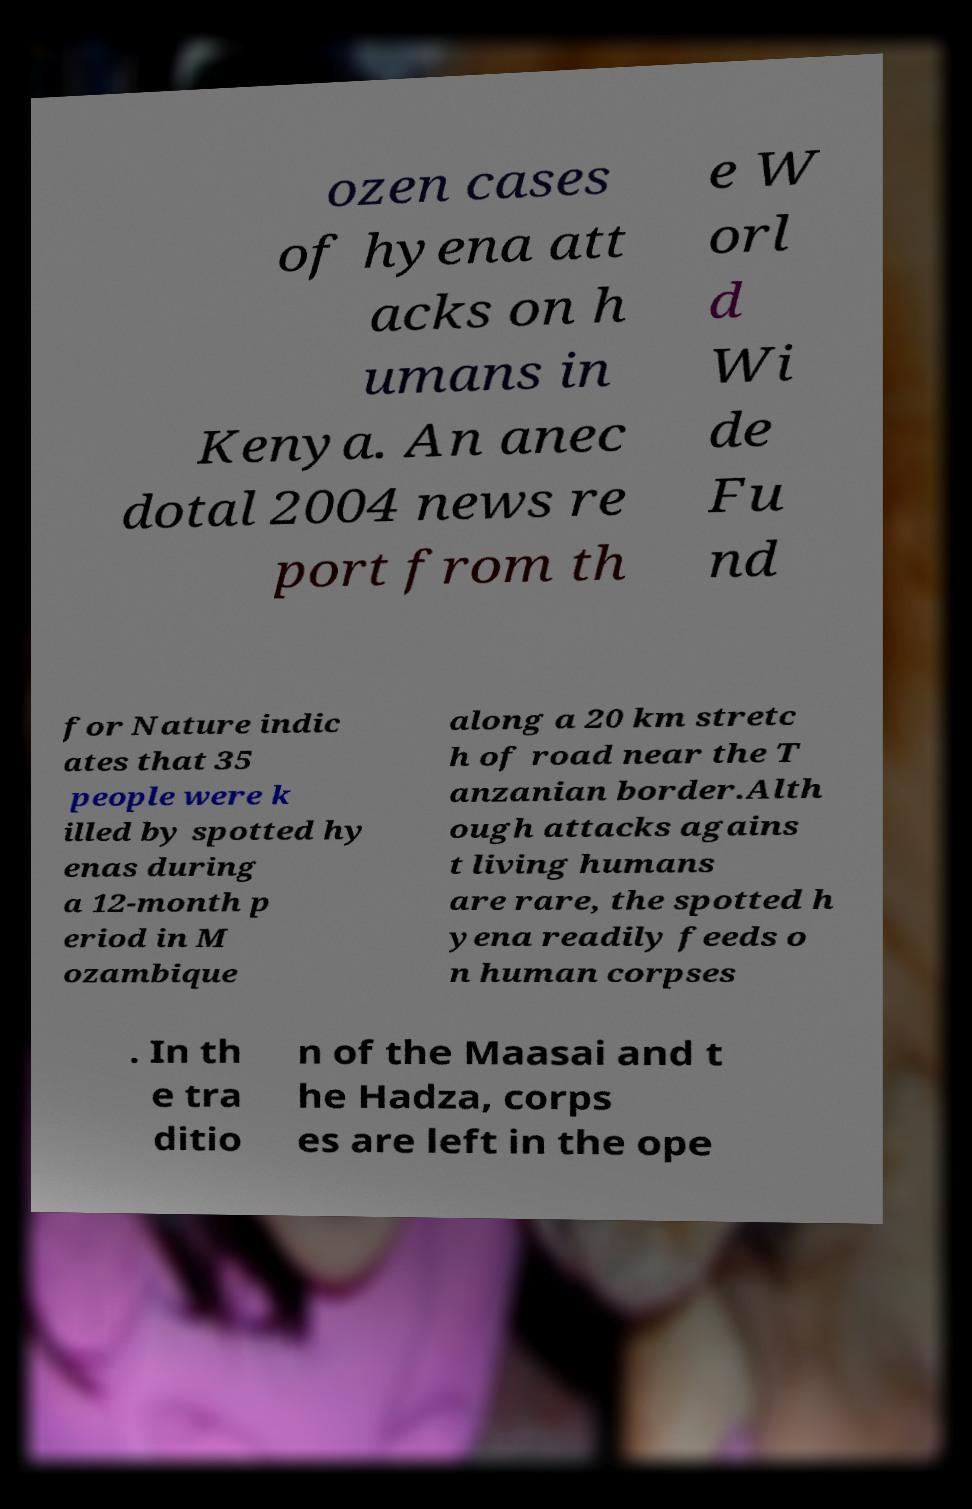Could you assist in decoding the text presented in this image and type it out clearly? ozen cases of hyena att acks on h umans in Kenya. An anec dotal 2004 news re port from th e W orl d Wi de Fu nd for Nature indic ates that 35 people were k illed by spotted hy enas during a 12-month p eriod in M ozambique along a 20 km stretc h of road near the T anzanian border.Alth ough attacks agains t living humans are rare, the spotted h yena readily feeds o n human corpses . In th e tra ditio n of the Maasai and t he Hadza, corps es are left in the ope 